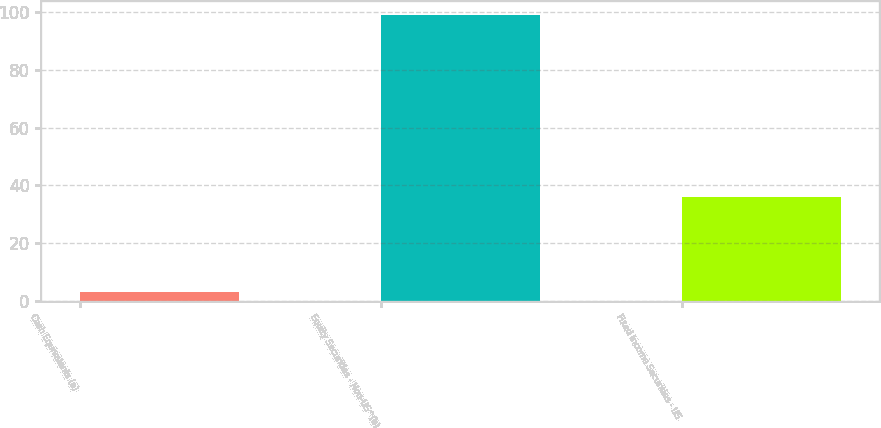Convert chart to OTSL. <chart><loc_0><loc_0><loc_500><loc_500><bar_chart><fcel>Cash Equivalents (a)<fcel>Equity Securities - Non-US^(b)<fcel>Fixed Income Securities - US<nl><fcel>3<fcel>99<fcel>36<nl></chart> 